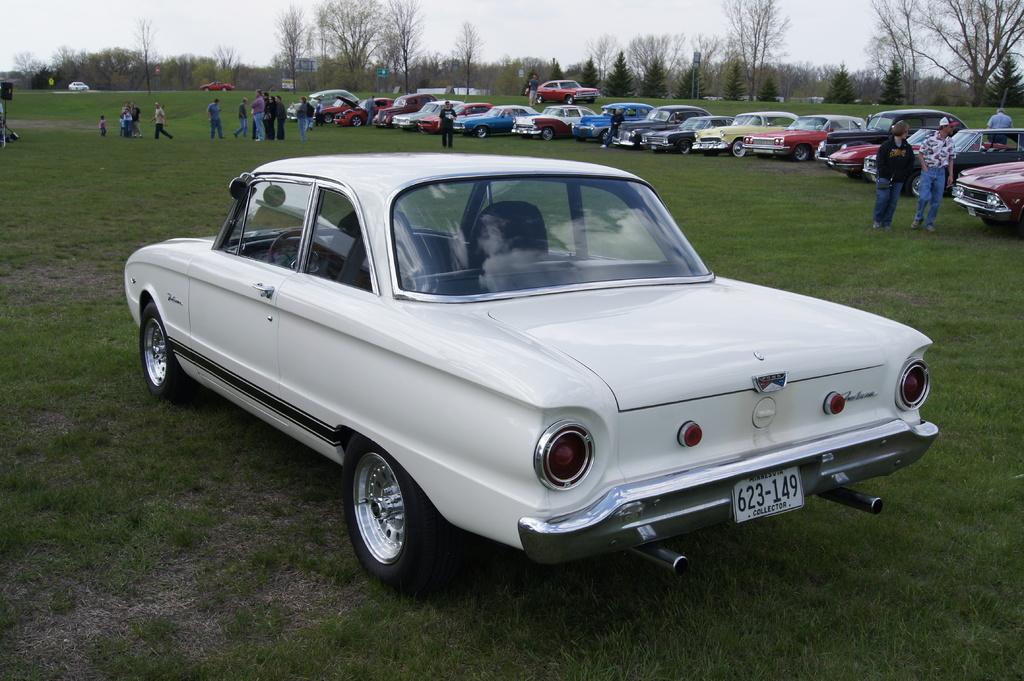Could you give a brief overview of what you see in this image? In this picture we can see some cars here, at the bottom there is grass, we can see some people standing, in the background there are some trees, we can see the sky at the top of the picture. 